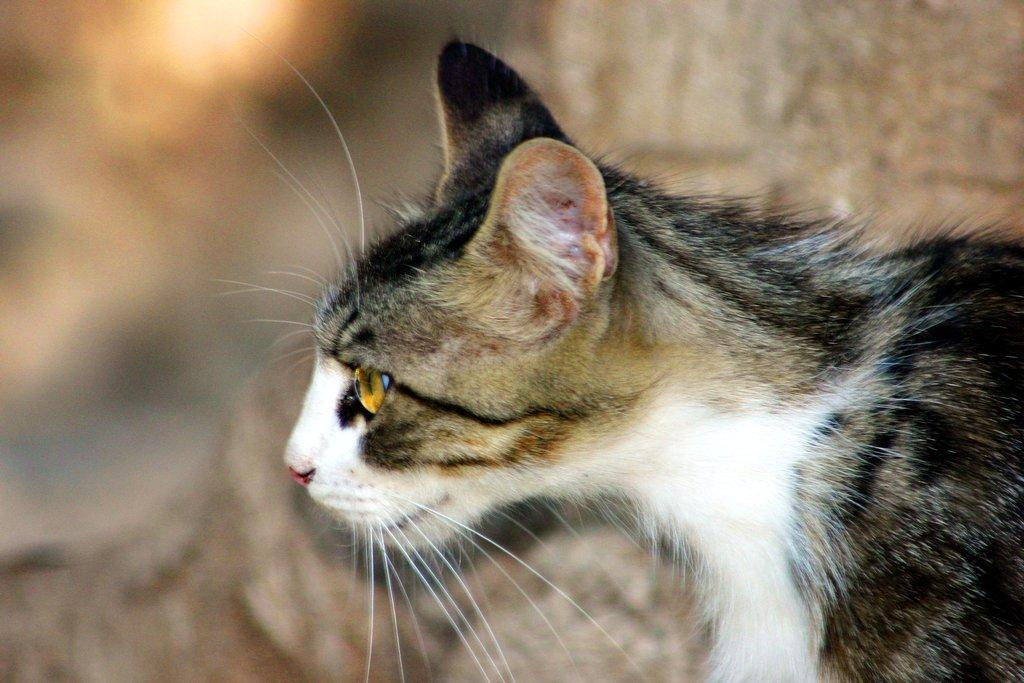Where was the image taken? The image was taken outdoors. Can you describe the background of the image? The background of the image is blurred. What type of animal can be seen on the right side of the image? There is a cat on the right side of the image. How many weeks does the cat spend planning its self-improvement goals in the image? There is no information about the cat's self-improvement goals or the passage of time in the image. 